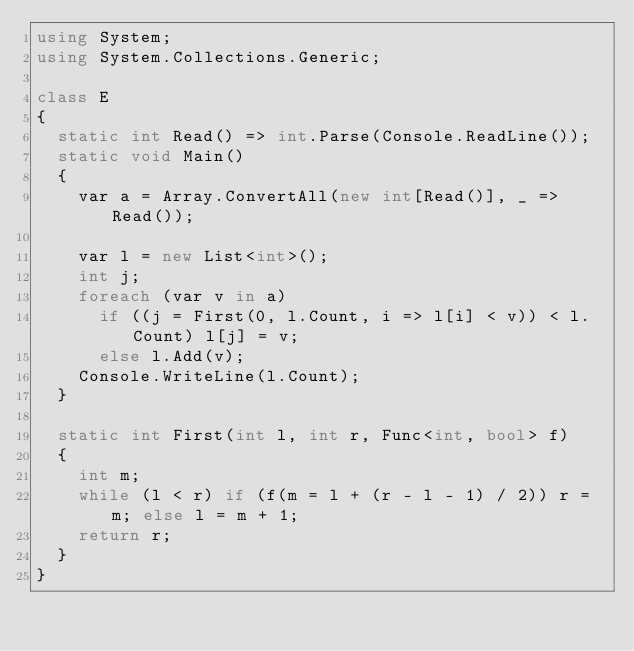Convert code to text. <code><loc_0><loc_0><loc_500><loc_500><_C#_>using System;
using System.Collections.Generic;

class E
{
	static int Read() => int.Parse(Console.ReadLine());
	static void Main()
	{
		var a = Array.ConvertAll(new int[Read()], _ => Read());

		var l = new List<int>();
		int j;
		foreach (var v in a)
			if ((j = First(0, l.Count, i => l[i] < v)) < l.Count) l[j] = v;
			else l.Add(v);
		Console.WriteLine(l.Count);
	}

	static int First(int l, int r, Func<int, bool> f)
	{
		int m;
		while (l < r) if (f(m = l + (r - l - 1) / 2)) r = m; else l = m + 1;
		return r;
	}
}
</code> 